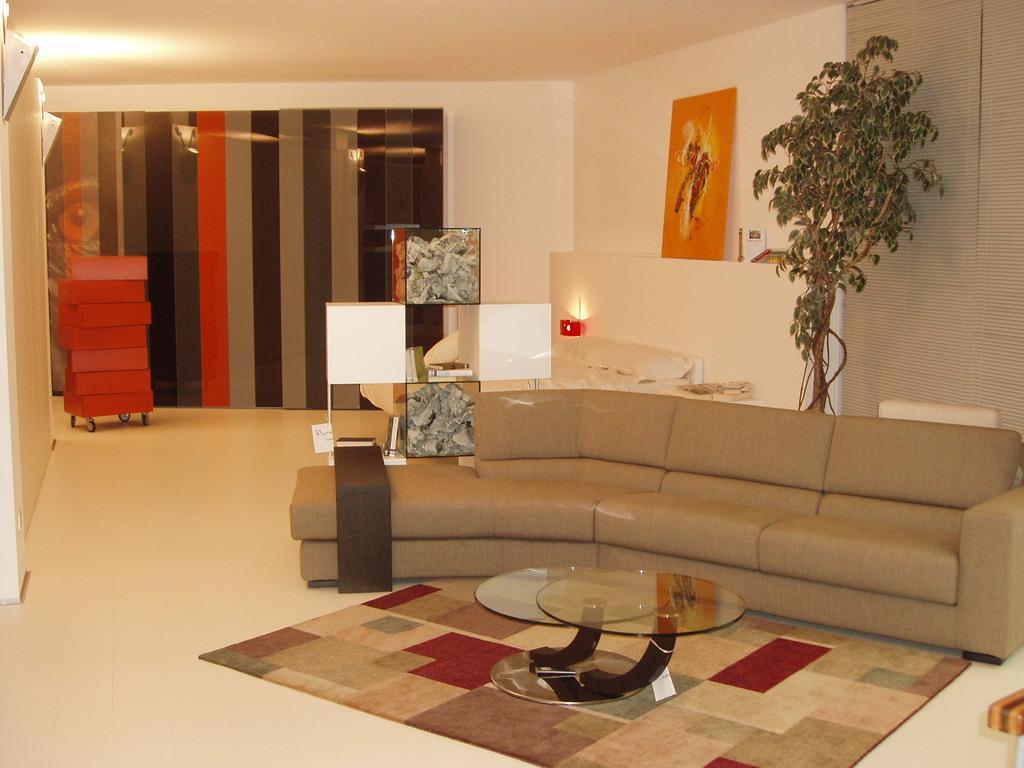Can you describe this image briefly? There is a sofa which has a glass table in front of it and there is a tree behind the sofa and the background wall is white in color. 